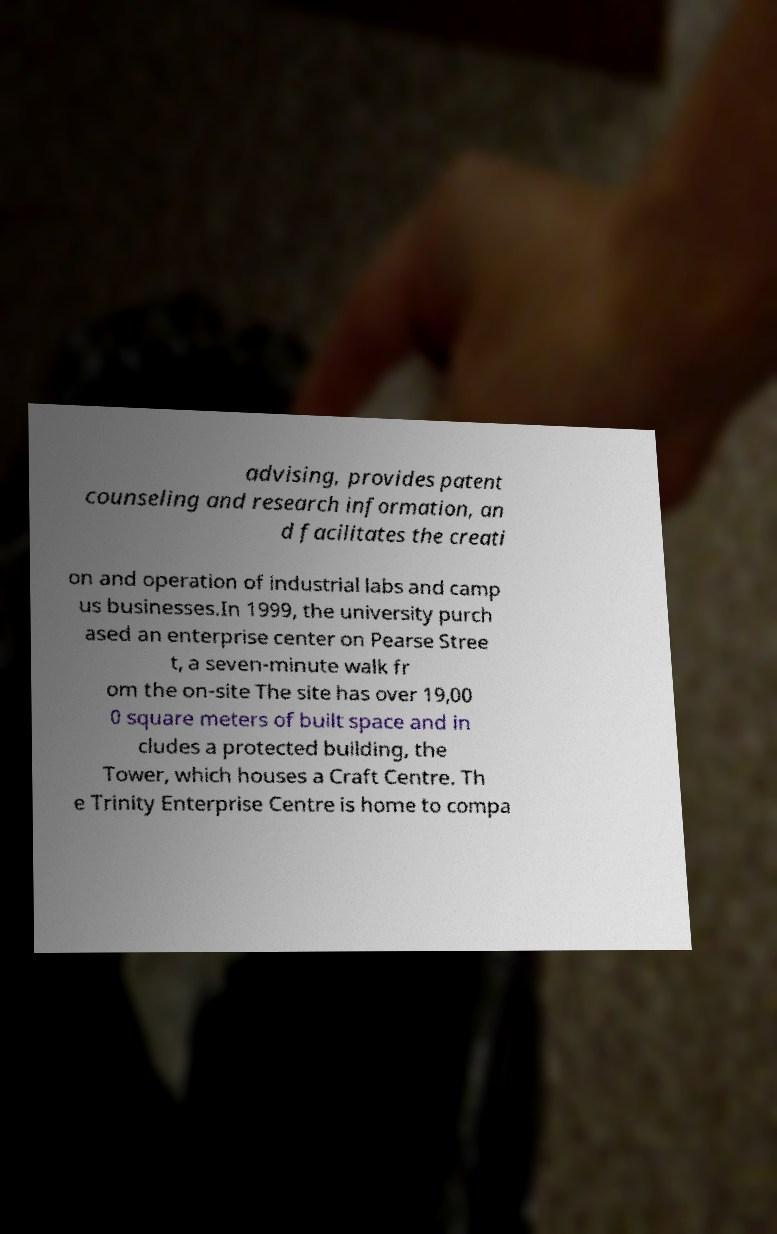For documentation purposes, I need the text within this image transcribed. Could you provide that? advising, provides patent counseling and research information, an d facilitates the creati on and operation of industrial labs and camp us businesses.In 1999, the university purch ased an enterprise center on Pearse Stree t, a seven-minute walk fr om the on-site The site has over 19,00 0 square meters of built space and in cludes a protected building, the Tower, which houses a Craft Centre. Th e Trinity Enterprise Centre is home to compa 